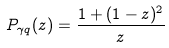Convert formula to latex. <formula><loc_0><loc_0><loc_500><loc_500>P _ { \gamma q } ( z ) = \frac { 1 + ( 1 - z ) ^ { 2 } } { z }</formula> 